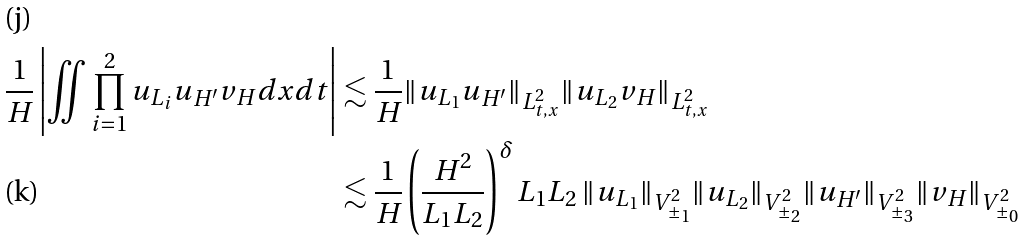<formula> <loc_0><loc_0><loc_500><loc_500>\frac { 1 } { H } \left | \iint \prod _ { i = 1 } ^ { 2 } u _ { L _ { i } } u _ { H ^ { \prime } } v _ { H } d x d t \right | & \lesssim \frac { 1 } { H } \| u _ { L _ { 1 } } u _ { H ^ { \prime } } \| _ { L _ { t , x } ^ { 2 } } \| u _ { L _ { 2 } } v _ { H } \| _ { L _ { t , x } ^ { 2 } } \\ & \lesssim \frac { 1 } { H } \left ( \frac { H ^ { 2 } } { L _ { 1 } L _ { 2 } } \right ) ^ { \delta } L _ { 1 } L _ { 2 } \, \| u _ { L _ { 1 } } \| _ { V _ { \pm _ { 1 } } ^ { 2 } } \| u _ { L _ { 2 } } \| _ { V _ { \pm _ { 2 } } ^ { 2 } } \| u _ { H ^ { \prime } } \| _ { V _ { \pm _ { 3 } } ^ { 2 } } \| v _ { H } \| _ { V _ { \pm _ { 0 } } ^ { 2 } }</formula> 